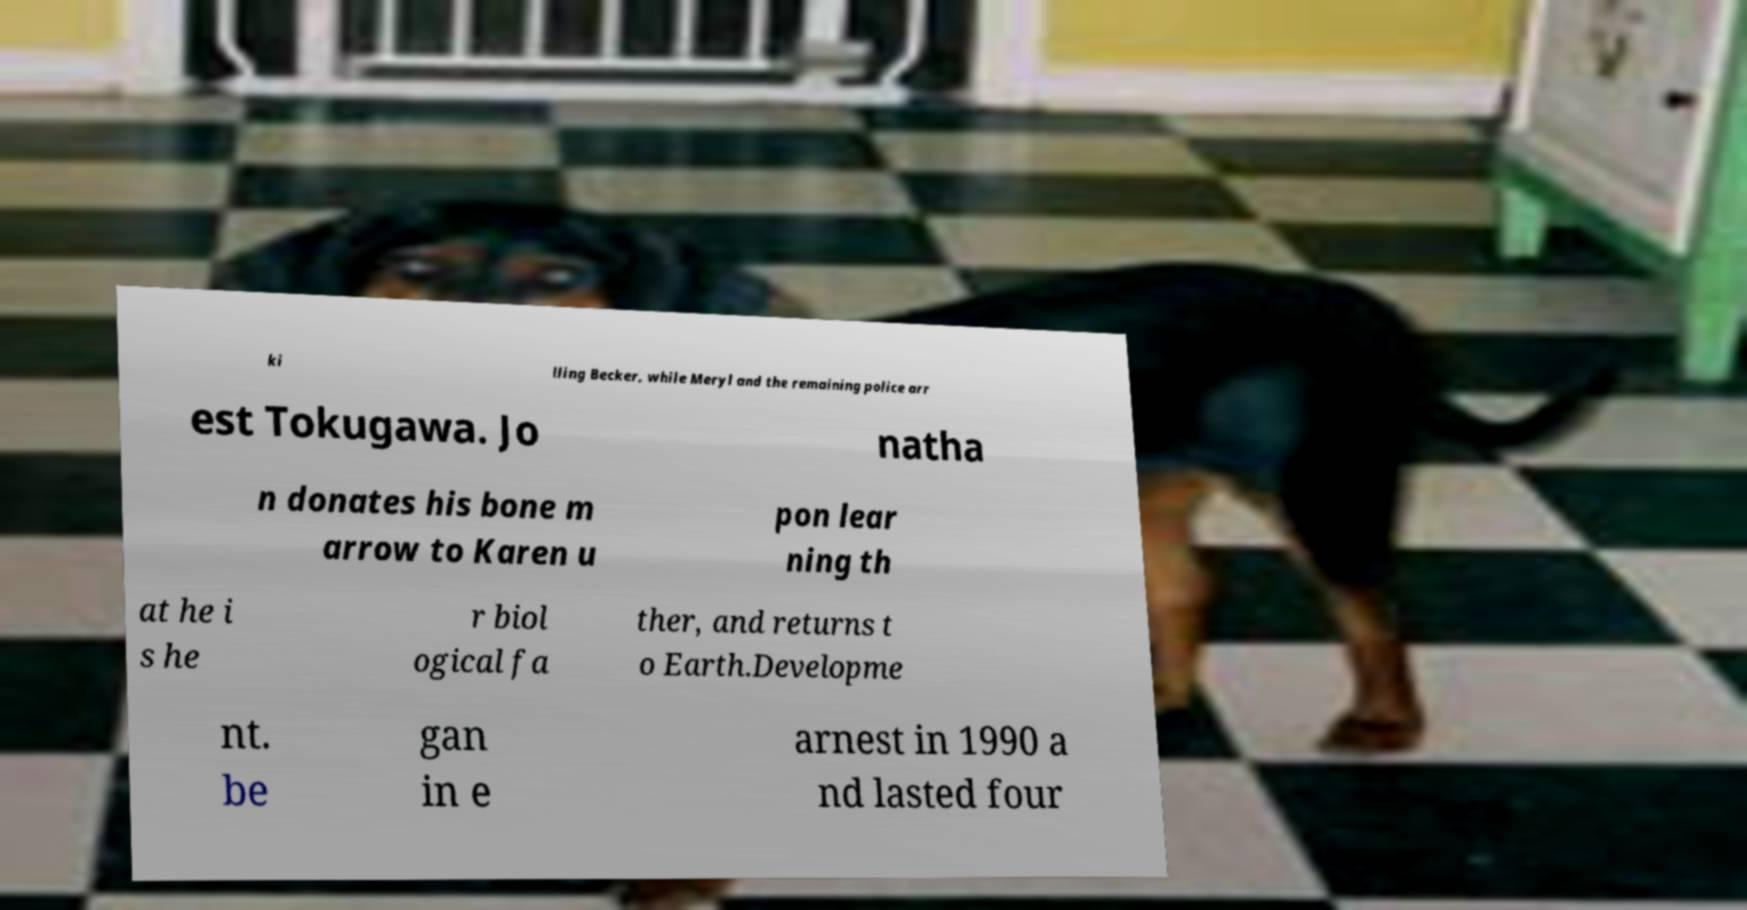Could you extract and type out the text from this image? ki lling Becker, while Meryl and the remaining police arr est Tokugawa. Jo natha n donates his bone m arrow to Karen u pon lear ning th at he i s he r biol ogical fa ther, and returns t o Earth.Developme nt. be gan in e arnest in 1990 a nd lasted four 